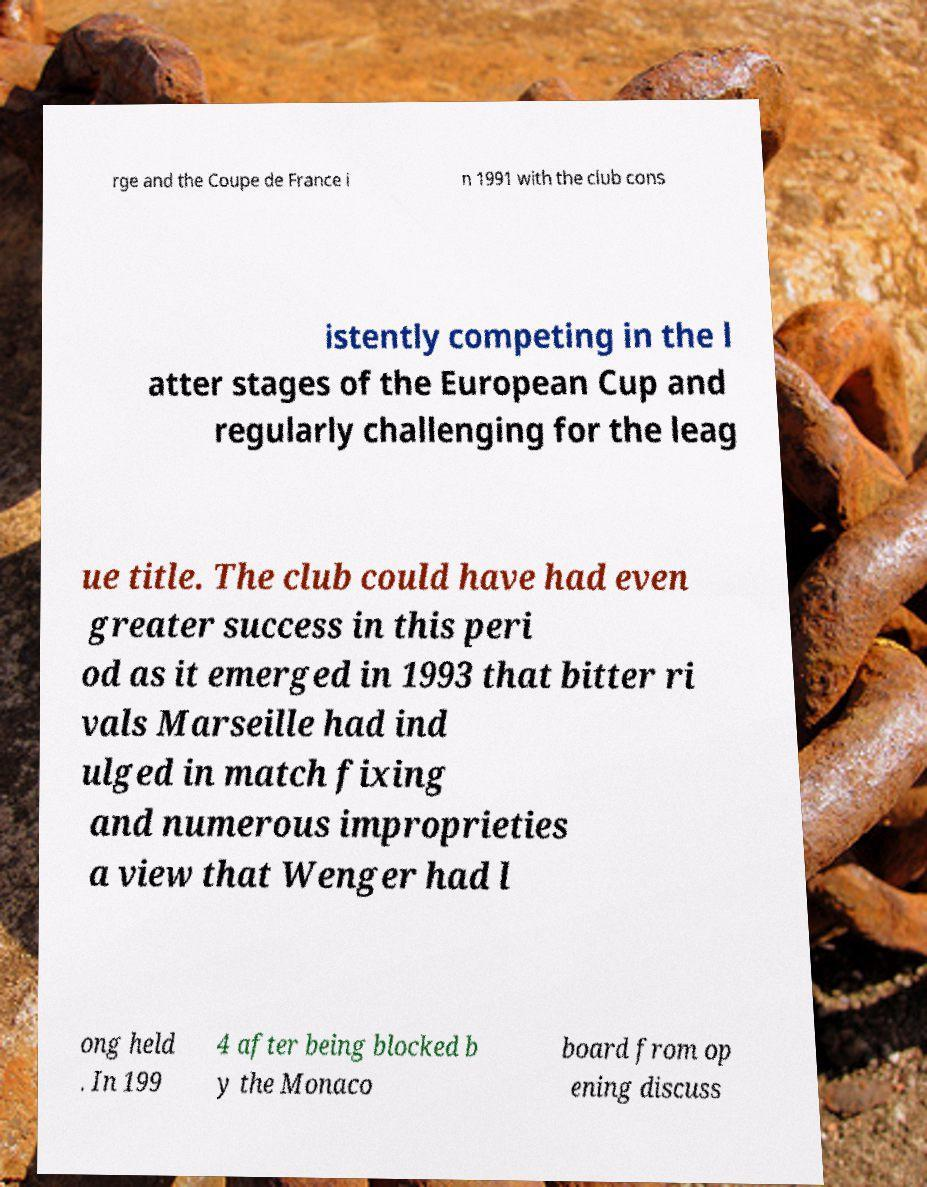Please identify and transcribe the text found in this image. rge and the Coupe de France i n 1991 with the club cons istently competing in the l atter stages of the European Cup and regularly challenging for the leag ue title. The club could have had even greater success in this peri od as it emerged in 1993 that bitter ri vals Marseille had ind ulged in match fixing and numerous improprieties a view that Wenger had l ong held . In 199 4 after being blocked b y the Monaco board from op ening discuss 